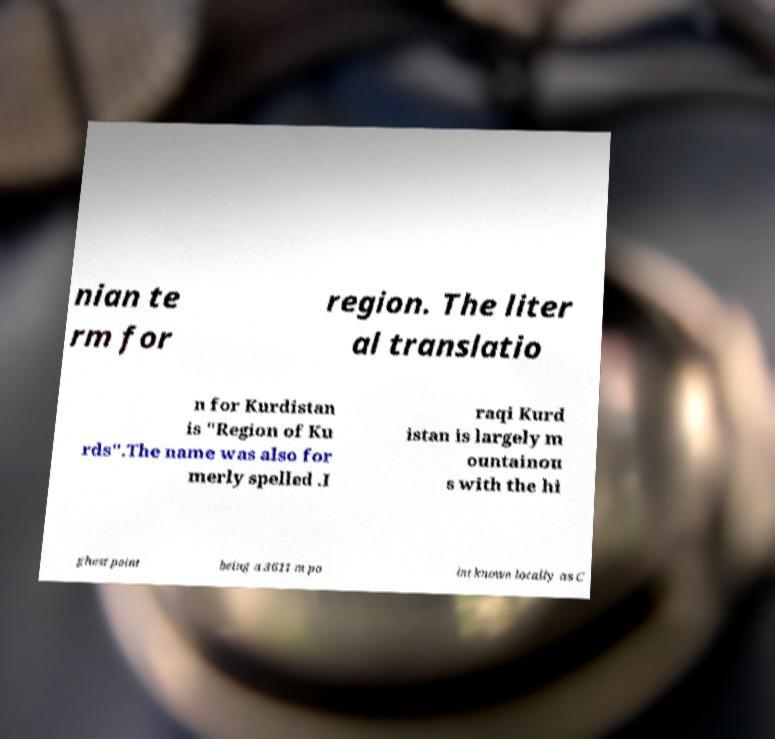What messages or text are displayed in this image? I need them in a readable, typed format. nian te rm for region. The liter al translatio n for Kurdistan is "Region of Ku rds".The name was also for merly spelled .I raqi Kurd istan is largely m ountainou s with the hi ghest point being a 3611 m po int known locally as C 